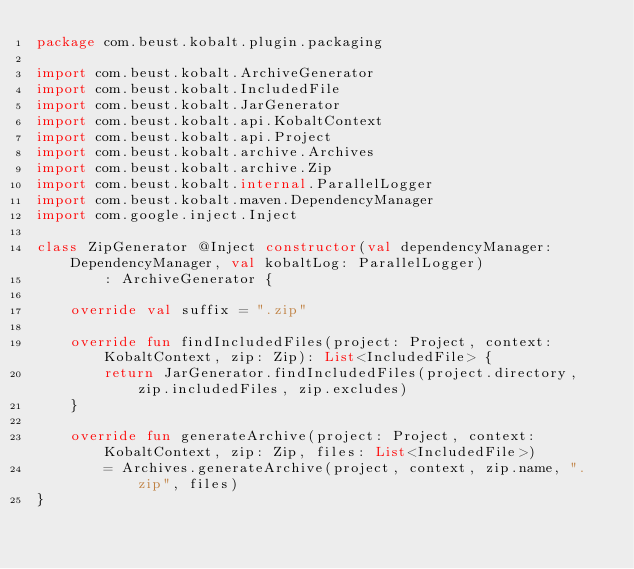<code> <loc_0><loc_0><loc_500><loc_500><_Kotlin_>package com.beust.kobalt.plugin.packaging

import com.beust.kobalt.ArchiveGenerator
import com.beust.kobalt.IncludedFile
import com.beust.kobalt.JarGenerator
import com.beust.kobalt.api.KobaltContext
import com.beust.kobalt.api.Project
import com.beust.kobalt.archive.Archives
import com.beust.kobalt.archive.Zip
import com.beust.kobalt.internal.ParallelLogger
import com.beust.kobalt.maven.DependencyManager
import com.google.inject.Inject

class ZipGenerator @Inject constructor(val dependencyManager: DependencyManager, val kobaltLog: ParallelLogger)
        : ArchiveGenerator {

    override val suffix = ".zip"

    override fun findIncludedFiles(project: Project, context: KobaltContext, zip: Zip): List<IncludedFile> {
        return JarGenerator.findIncludedFiles(project.directory, zip.includedFiles, zip.excludes)
    }

    override fun generateArchive(project: Project, context: KobaltContext, zip: Zip, files: List<IncludedFile>)
        = Archives.generateArchive(project, context, zip.name, ".zip", files)
}
</code> 